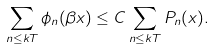<formula> <loc_0><loc_0><loc_500><loc_500>\sum _ { n \leq k T } \phi _ { n } ( \beta x ) \leq C \sum _ { n \leq k T } P _ { n } ( x ) .</formula> 